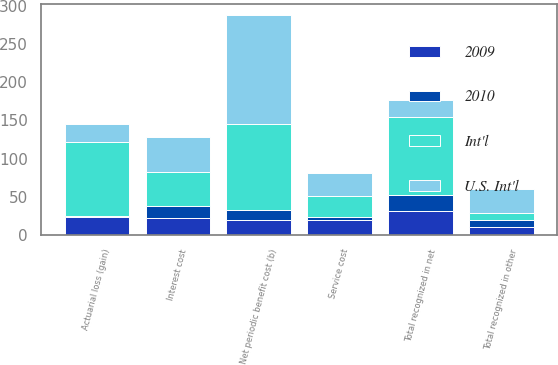<chart> <loc_0><loc_0><loc_500><loc_500><stacked_bar_chart><ecel><fcel>Service cost<fcel>Interest cost<fcel>Net periodic benefit cost (b)<fcel>Actuarial loss (gain)<fcel>Total recognized in other<fcel>Total recognized in net<nl><fcel>Int'l<fcel>28<fcel>44<fcel>112<fcel>97<fcel>10<fcel>102<nl><fcel>2009<fcel>19<fcel>22<fcel>20<fcel>24<fcel>11<fcel>31<nl><fcel>U.S. Int'l<fcel>30<fcel>47<fcel>143<fcel>23<fcel>31<fcel>23<nl><fcel>2010<fcel>4<fcel>16<fcel>13<fcel>1<fcel>8<fcel>21<nl></chart> 